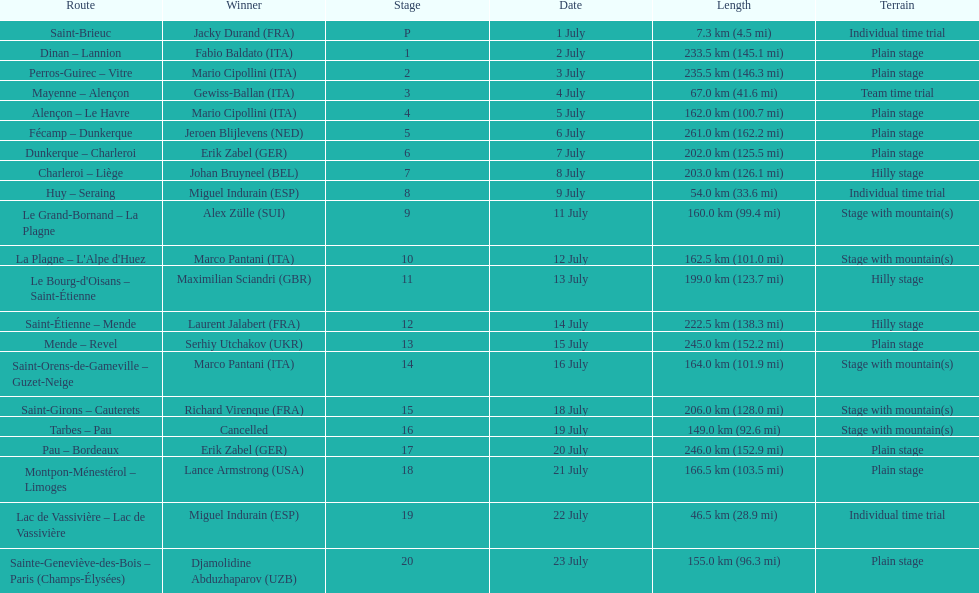After lance armstrong, who led next in the 1995 tour de france? Miguel Indurain. 